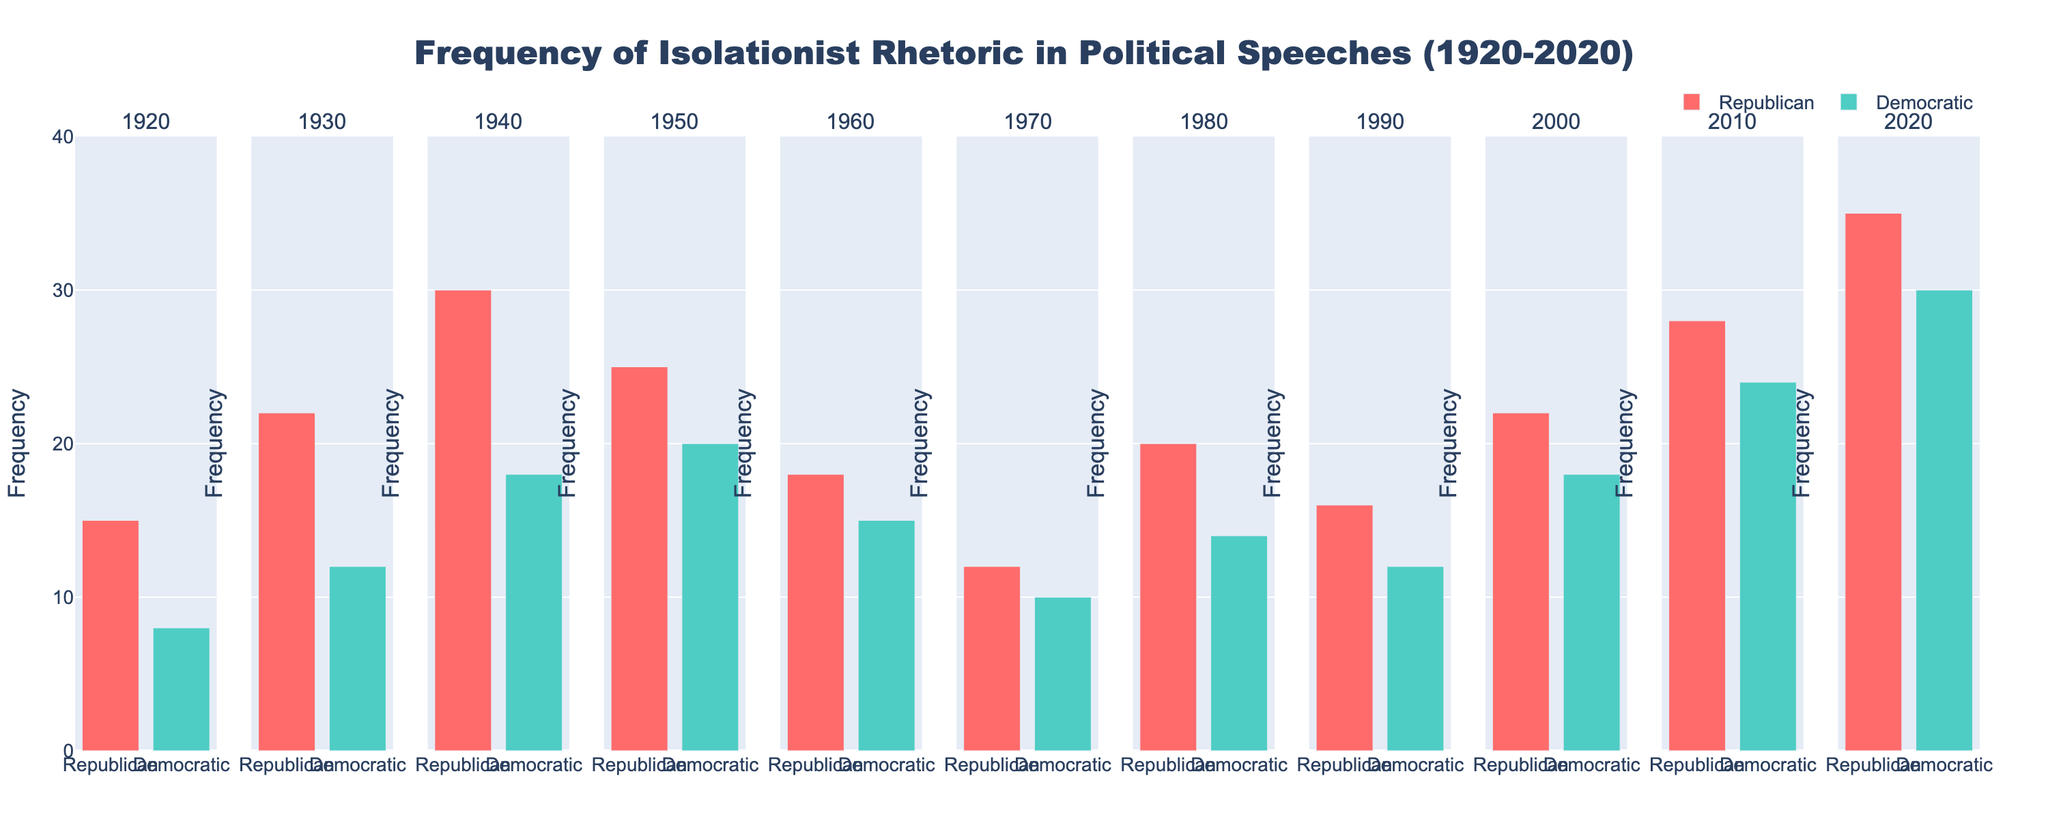Which party shows the highest frequency of isolationist rhetoric in the year 2020? In the subplot for the year 2020, compare the heights of the bars for the Republican and Democratic parties. The Republican bar is higher.
Answer: Republican What trend do you see in the frequency of isolationist rhetoric from 1920 to 2020 in the Democratic party? Look across the subplots for the Democratic party from left to right. The height of the bars generally increases over time.
Answer: Increasing trend How does the frequency of isolationist rhetoric in 1940 for the Republican party compare to the Democratic party? In the subplot for the year 1940, compare the heights of the bars. The Republican bar is taller than the Democratic bar.
Answer: Higher Which year shows the smallest difference in frequency between the two parties? Look for bars that are close in height within each subplot. The subplot for 1970 shows the smallest difference with the Republican bar at 12 and Democratic bar at 10.
Answer: 1970 What is the average frequency of isolationist rhetoric for the Republican party over the entire period shown? Sum the frequencies for the Republican party (15 + 22 + 30 + 25 + 18 + 12 + 20 + 16 + 22 + 28 + 35 = 243) and divide by the number of years (11). 243 / 11 ≈ 22.09
Answer: 22.09 In which decade does the Democratic party have the highest isolationist rhetoric? Compare the bars for the Democratic party across decades. The highest bar is in the 2020 subplot.
Answer: 2020s What is the total frequency of isolationist rhetoric for both parties combined in 1960? Sum the frequencies for 1960: Republican (18) + Democratic (15) = 33
Answer: 33 Which decade showed the largest drop in isolationist rhetoric for the Republican party? Compare the differences between bars across consecutive decades for the Republican party. The largest drop is from 1940 (30) to 1950 (25), a drop of 5 points.
Answer: 1940 to 1950 Is there any year where both parties have the same frequency of isolationist rhetoric? Check each subplot to see if the bars for both parties are the same height. None of the subplots show equal heights.
Answer: No How does the frequency of isolationist rhetoric in 2000 compare between the two parties? In the subplot for the year 2000, compare the heights of the bars. The Republican bar (22) is taller than the Democratic bar (18).
Answer: Republican higher 